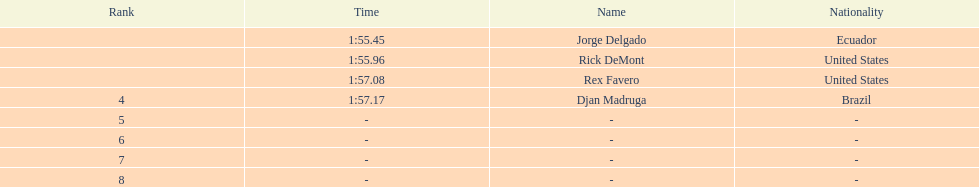Who finished with the top time? Jorge Delgado. 